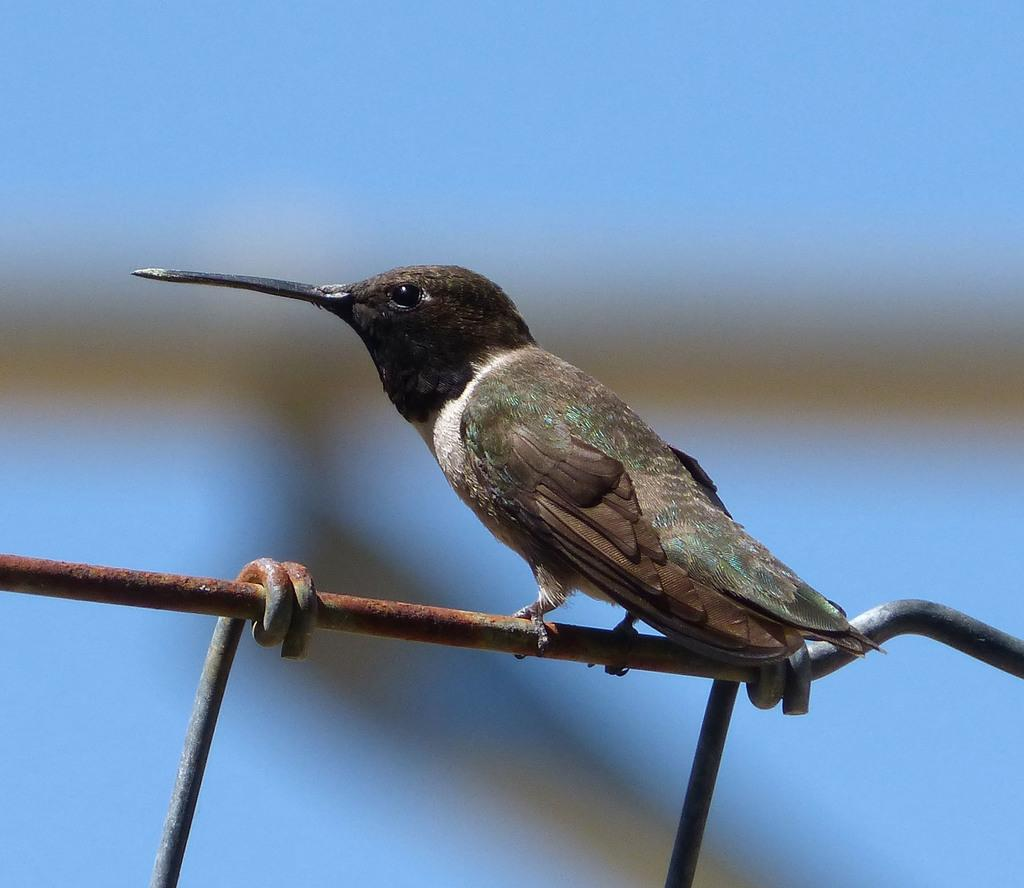What type of bird is in the image? There is a sparrow in the image. Where is the sparrow located? The sparrow is sitting on a metal rod. What is the color scheme of the image? The image is in black color. How would you describe the background of the image? The background of the image is blurred. What book is the sparrow reading in the image? There is no book or reading activity present in the image; it features a sparrow sitting on a metal rod. 